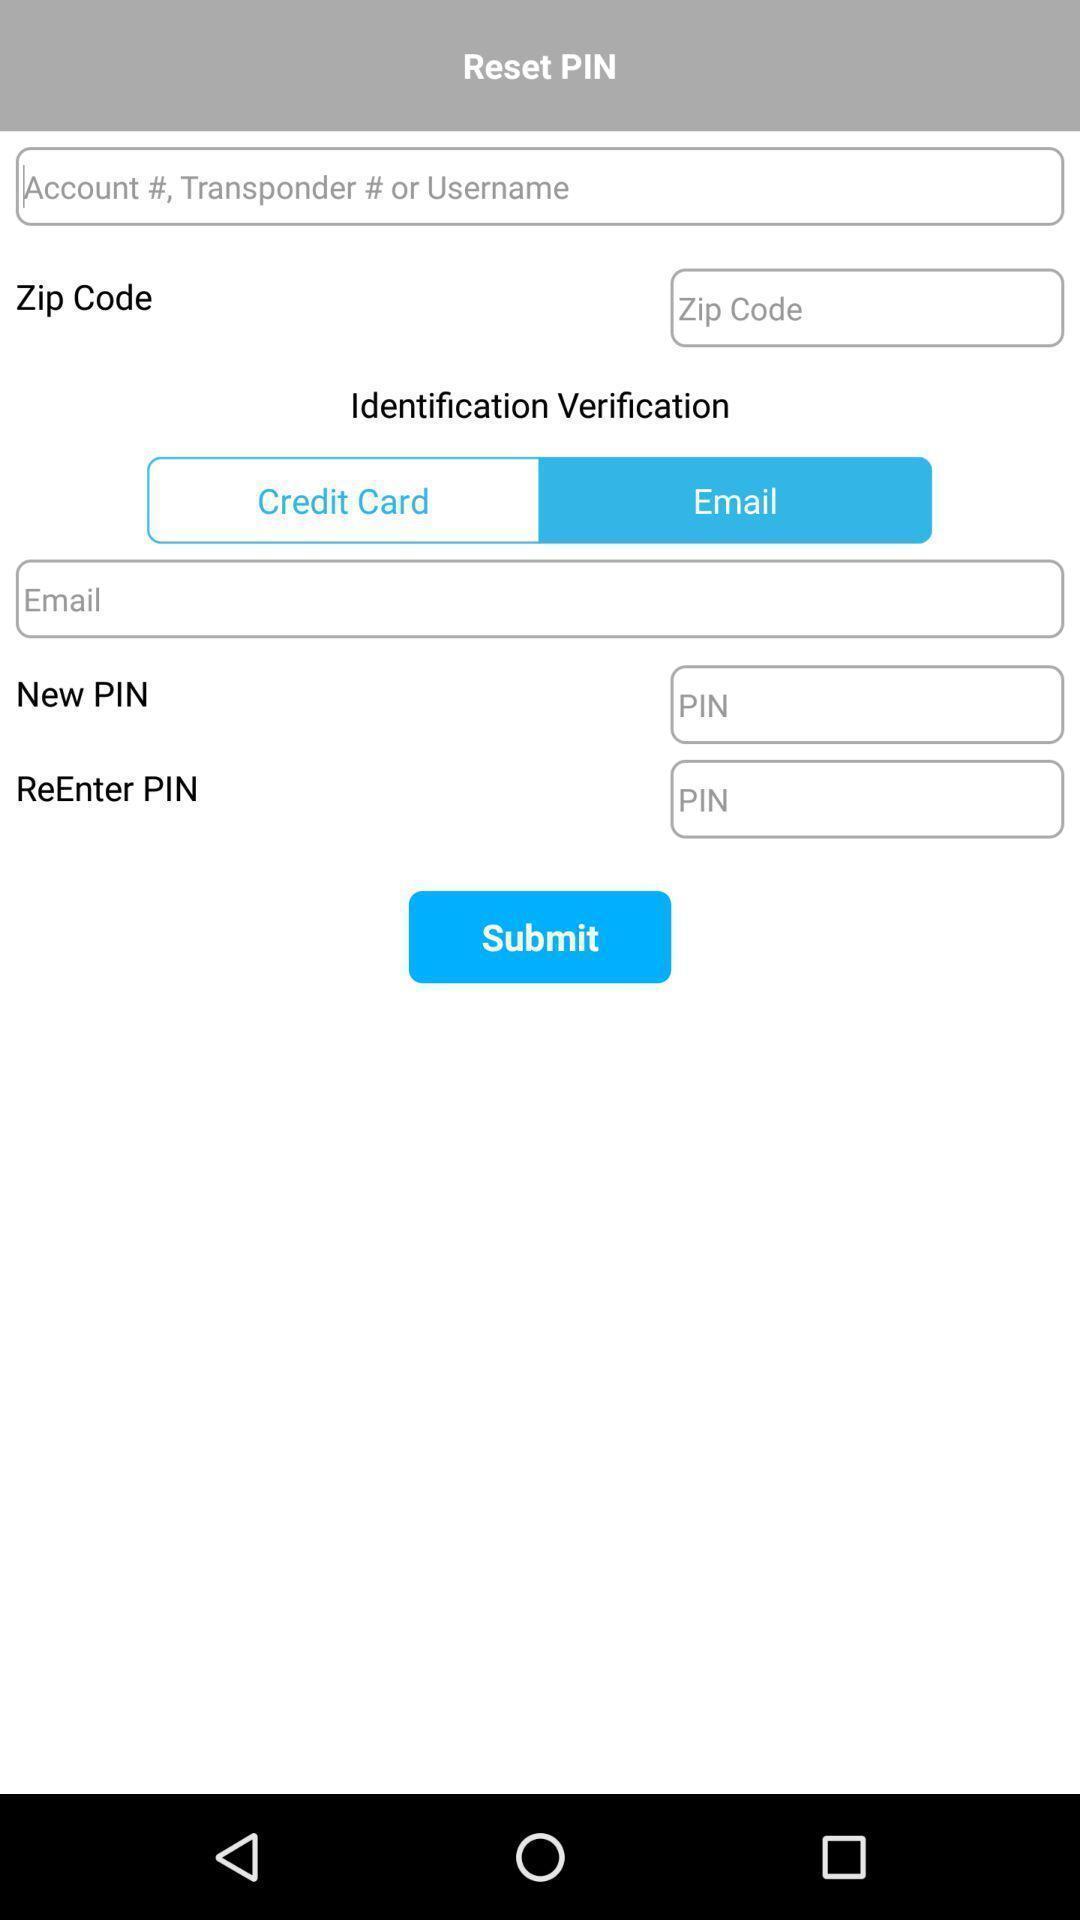Give me a narrative description of this picture. Page to reset pin. 